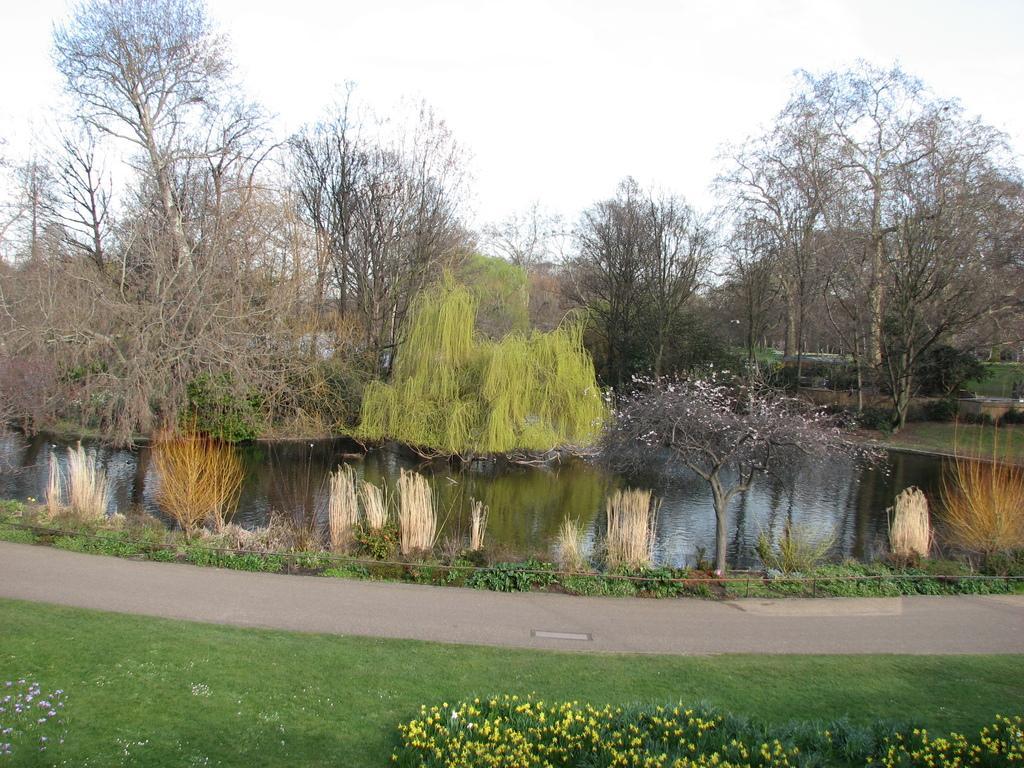Can you describe this image briefly? In this image I can see some grass on the ground, few plants, few flowers which are yellow in color, the road, the water and few trees. In the background I can see the sky. 